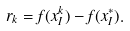<formula> <loc_0><loc_0><loc_500><loc_500>r _ { k } = f ( x _ { I } ^ { k } ) - f ( x ^ { * } _ { I } ) .</formula> 